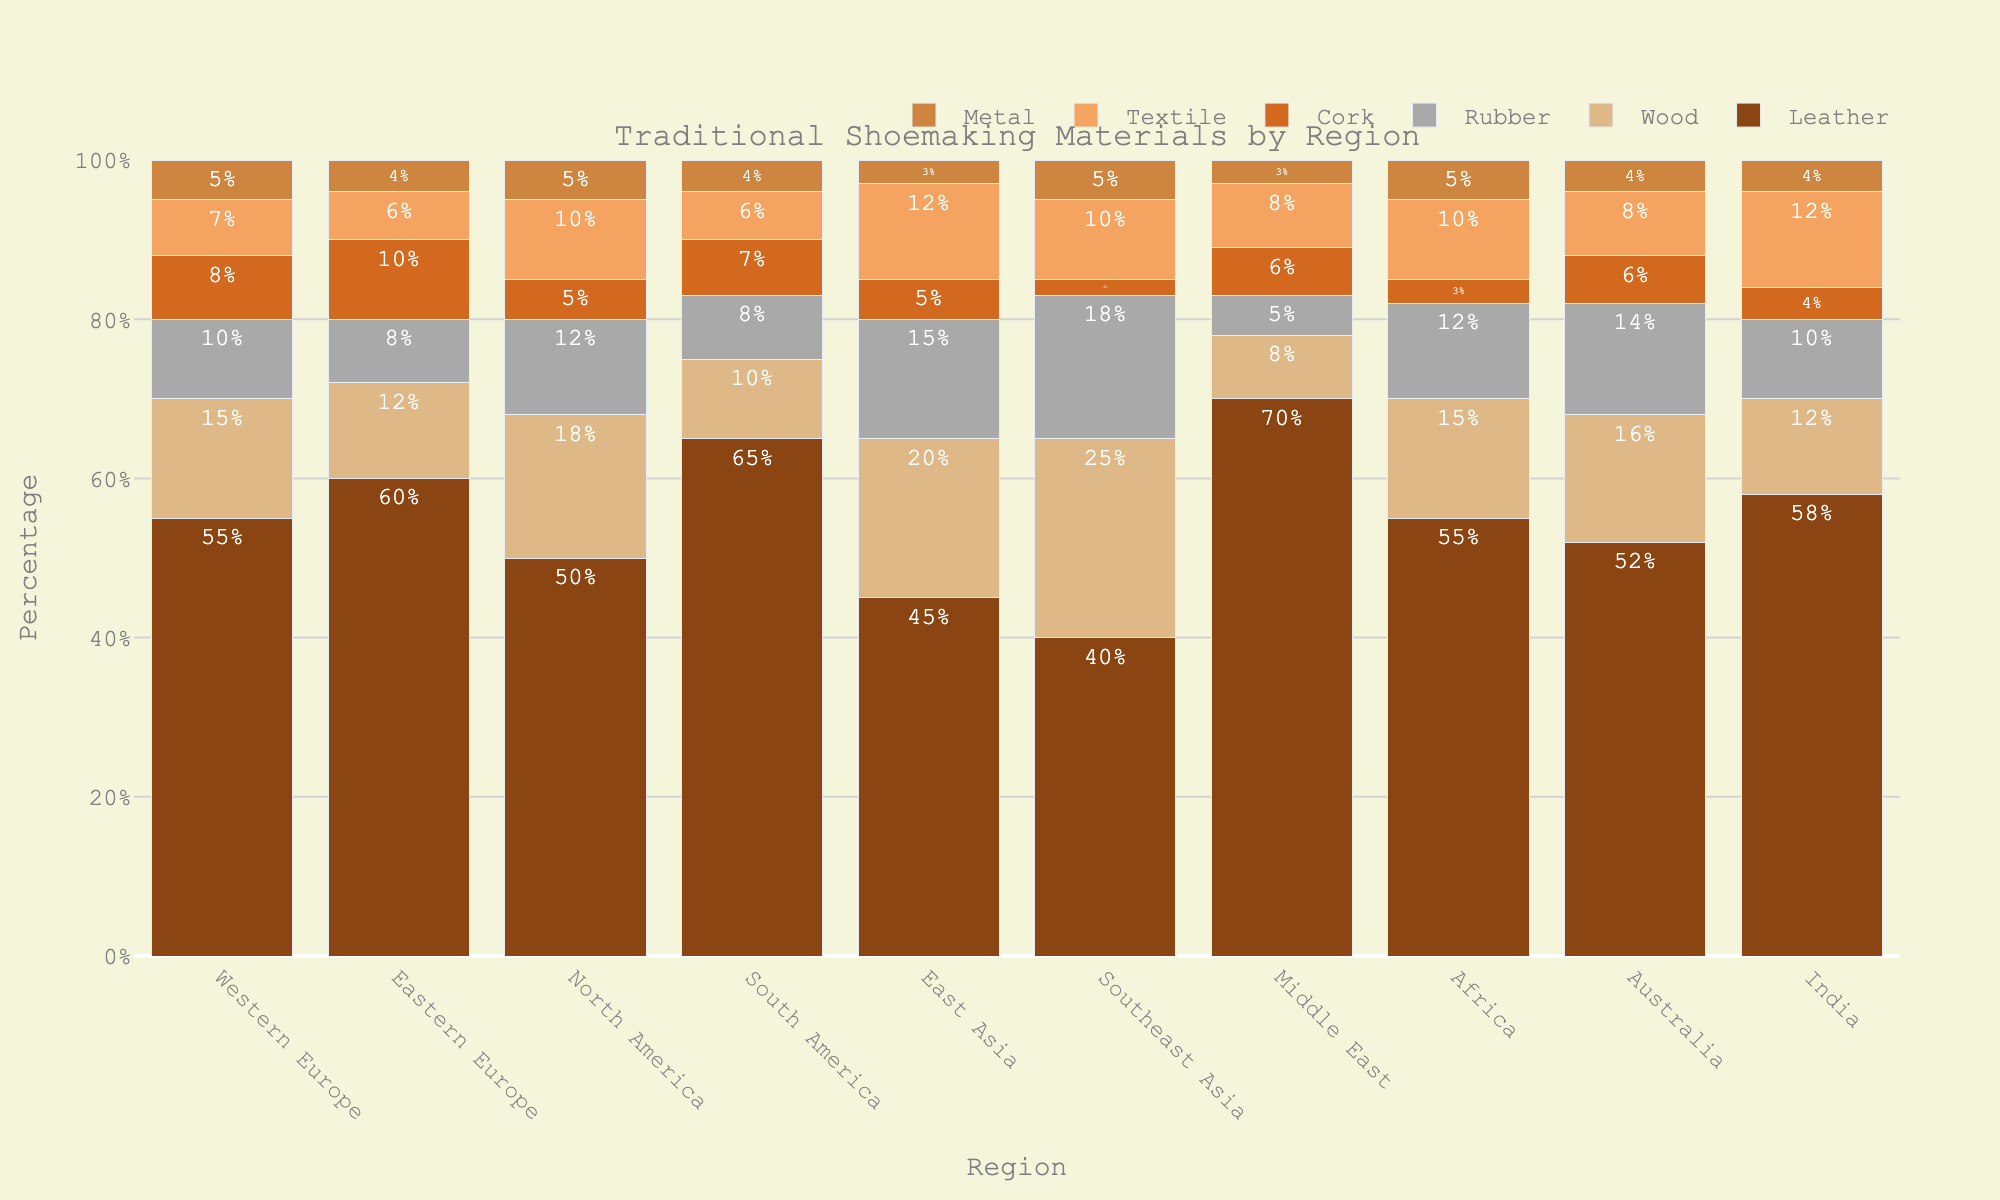What region uses the highest percentage of leather? By examining the height of the leather bars across all regions, the Middle East has the tallest bar at 70%, indicating it uses the highest percentage.
Answer: Middle East Which region has the lowest percentage of textile? By comparing the height of the textile bars, Southeast Asia has the shortest bar at 2%, showing it has the lowest percentage.
Answer: Southeast Asia What is the total percentage of wood and rubber used in Western Europe? Add the wood percentage (15%) and rubber percentage (10%) for Western Europe: 15 + 10 = 25%.
Answer: 25% In which region is the use of cork and metal equal? By checking the cork and metal bars across regions, Australia has both cork and metal at 6% and 4%, respectively, indicating they are equal.
Answer: Australia Compare the sum of leather, cork, and metal percentages between Eastern Europe and Australia. Which region has a higher total? For Eastern Europe: 60 (leather) + 10 (cork) + 4 (metal) = 74. For Australia: 52 (leather) + 6 (cork) + 4 (metal) = 62. Eastern Europe has a higher total.
Answer: Eastern Europe Which region uses rubber most compared to the others? By comparing the rubber bars, Southeast Asia has the tallest bar at 18%, indicating it uses rubber the most.
Answer: Southeast Asia What is the average percentage use of leather across all regions? Sum the leather percentages across regions (55+60+50+65+45+40+70+55+52+58 = 510) and divide by the number of regions (10): 510 / 10 = 51%.
Answer: 51% Which region has a more balanced use of materials with the least variance? Examine the bars for each region for a balanced distribution; Australia shows relatively similar bar heights across materials, indicating a more balanced use with the least variance.
Answer: Australia If you combined the percentages of rubber and textile for North America, would it be more or less than their leather usage? Add rubber (12%) and textile (10%) percentages for North America: 12 + 10 = 22%. Their leather usage is 50%, so the combined percentage is less than leather usage.
Answer: Less Which two regions have identical percentages for any material? By examining all material bars, both Western Europe and Africa have identical percentages for rubber (12%) and metal (5%).
Answer: Western Europe and Africa 